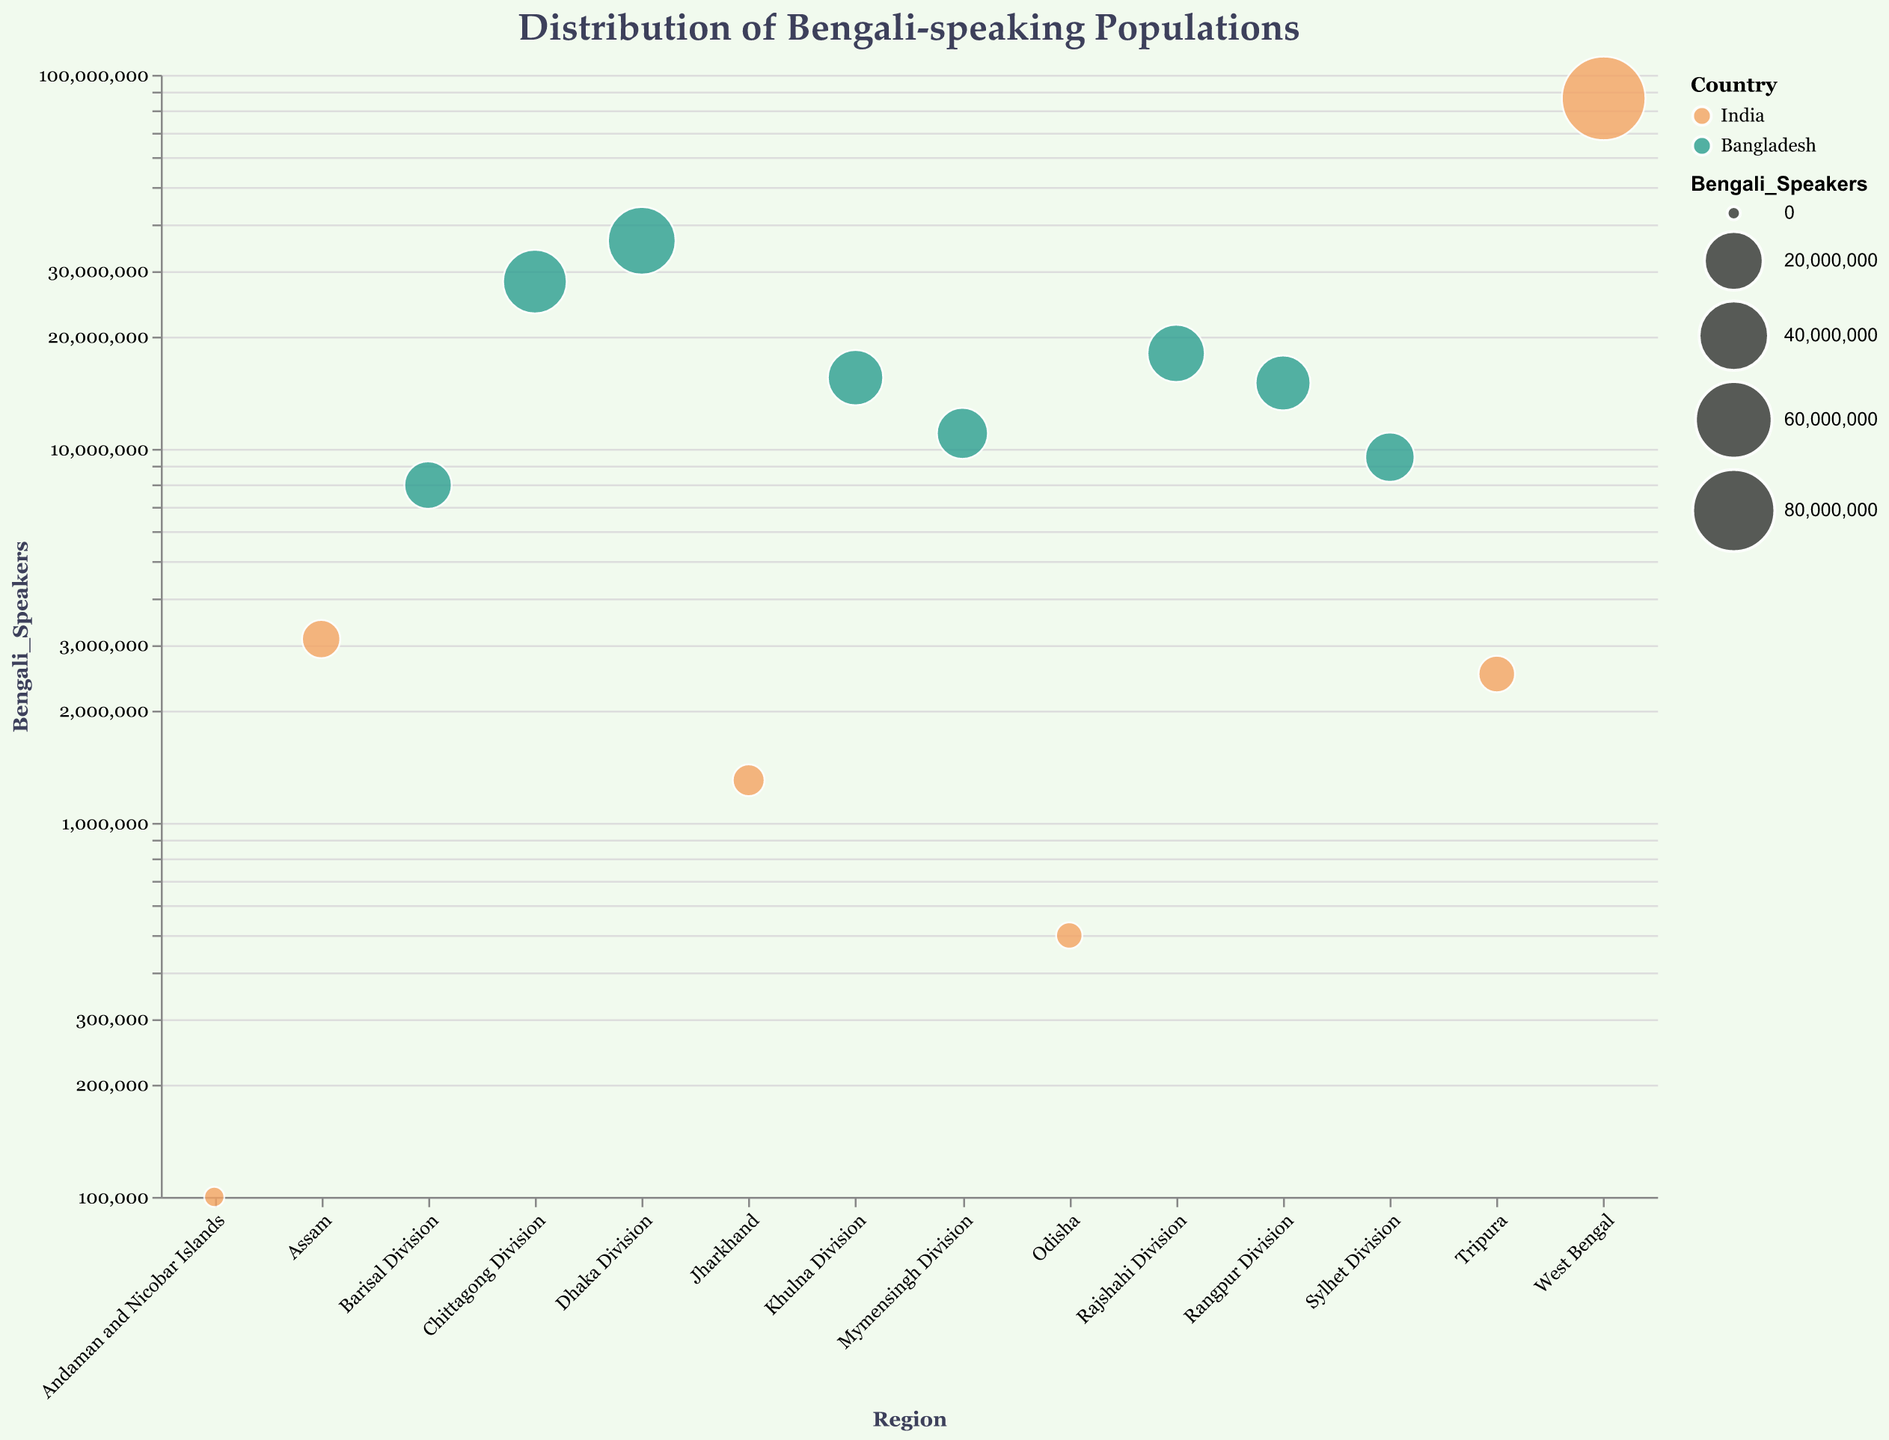What is the total number of Bengali speakers in India? To find the total number of Bengali speakers in India, sum the values for West Bengal, Tripura, Assam, Andaman and Nicobar Islands, Jharkhand, and Odisha. The calculation is 86,500,000 + 2,500,000 + 3,100,000 + 100,000 + 1,300,000 + 500,000 = 94,000,000 Bengali speakers.
Answer: 94,000,000 Which region has the highest number of Bengali speakers, and how many are there? The region with the highest number of Bengali speakers is West Bengal with 86,500,000 Bengali speakers.
Answer: West Bengal, 86,500,000 How does the number of Bengali speakers in Dhaka Division compare to that in West Bengal? Dhaka Division has 36,000,000 Bengali speakers while West Bengal has 86,500,000. Therefore, West Bengal has more Bengali speakers than Dhaka Division.
Answer: West Bengal has more Bengali speakers Which regions in Bangladesh have more than 20,000,000 Bengali speakers? To find this, look for regions in Bangladesh with Bengali speakers exceeding 20,000,000. Dhaka Division and Chittagong Division both have more than 20,000,000 Bengali speakers (Dhaka: 36,000,000, Chittagong: 28,000,000).
Answer: Dhaka Division, Chittagong Division What is the ratio of Bengali speakers in Khulna Division to those in Tripura? The number of Bengali speakers in Khulna Division is 15,500,000 and in Tripura is 2,500,000. The ratio is 15,500,000 / 2,500,000 = 6.2.
Answer: 6.2 What is the average number of Bengali speakers in the regions of Bangladesh? To find the average number of Bengali speakers in Bangladesh, sum the Bengali speakers from all Bangladeshi regions and divide by the number of regions. The sum is 36,000,000 + 28,000,000 + 18,000,000 + 15,500,000 + 9,500,000 + 8,000,000 + 15,000,000 + 11,000,000 = 141,000,000. There are 8 regions in Bangladesh, so the average is 141,000,000 / 8 = 17,625,000.
Answer: 17,625,000 Which Indian state/union territory has the least number of Bengali speakers, and how many speakers are there? The region with the least number of Bengali speakers in India is the Andaman and Nicobar Islands with 100,000 Bengali speakers.
Answer: Andaman and Nicobar Islands, 100,000 What are the combined Bengali-speaking populations of Assam and Odisha? The combined number of Bengali speakers in Assam and Odisha is 3,100,000 + 500,000 = 3,600,000.
Answer: 3,600,000 How does the size of the circle represent the number of Bengali speakers in the plot? The size of the circle in the plot represents the number of Bengali speakers, with larger circles indicating more speakers. This is determined by using a power scale with an exponent of 0.5, which modifies how the circle size grows with the number of speakers.
Answer: Larger circle indicates more speakers 